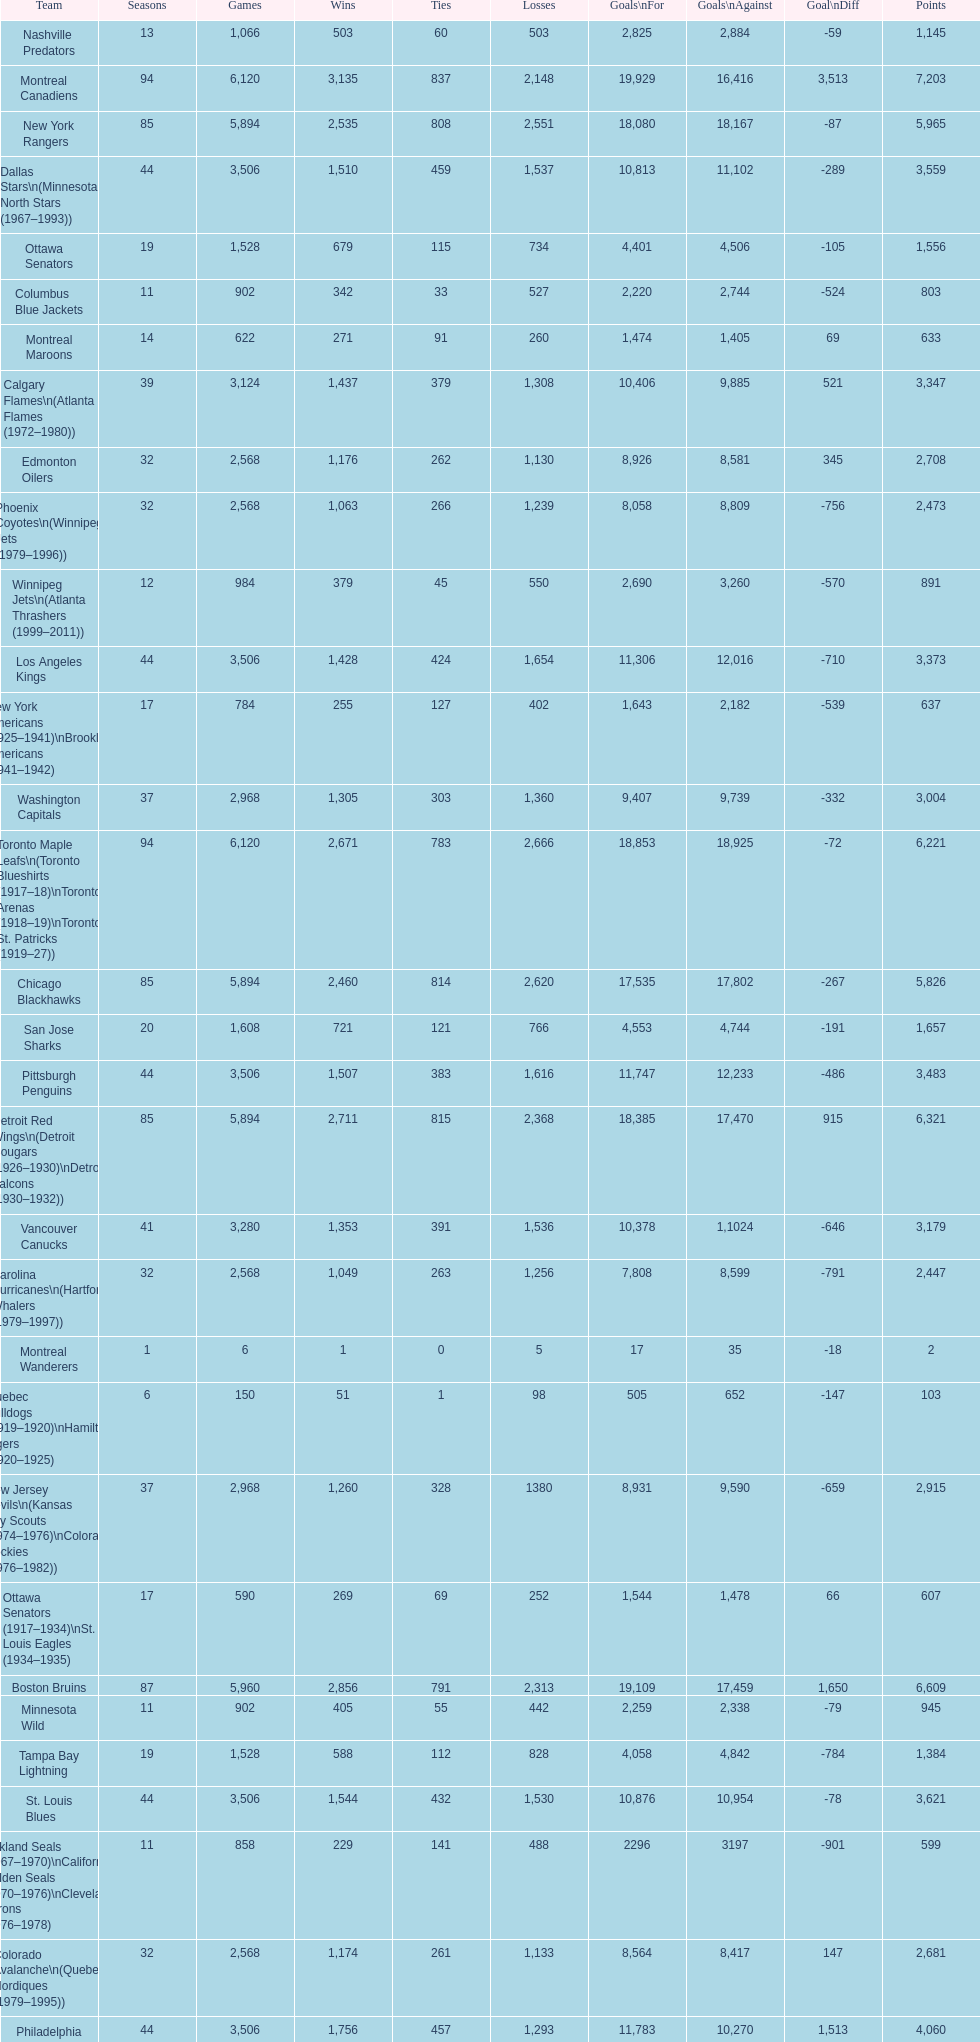How many losses do the st. louis blues have? 1,530. Can you give me this table as a dict? {'header': ['Team', 'Seasons', 'Games', 'Wins', 'Ties', 'Losses', 'Goals\\nFor', 'Goals\\nAgainst', 'Goal\\nDiff', 'Points'], 'rows': [['Nashville Predators', '13', '1,066', '503', '60', '503', '2,825', '2,884', '-59', '1,145'], ['Montreal Canadiens', '94', '6,120', '3,135', '837', '2,148', '19,929', '16,416', '3,513', '7,203'], ['New York Rangers', '85', '5,894', '2,535', '808', '2,551', '18,080', '18,167', '-87', '5,965'], ['Dallas Stars\\n(Minnesota North Stars (1967–1993))', '44', '3,506', '1,510', '459', '1,537', '10,813', '11,102', '-289', '3,559'], ['Ottawa Senators', '19', '1,528', '679', '115', '734', '4,401', '4,506', '-105', '1,556'], ['Columbus Blue Jackets', '11', '902', '342', '33', '527', '2,220', '2,744', '-524', '803'], ['Montreal Maroons', '14', '622', '271', '91', '260', '1,474', '1,405', '69', '633'], ['Calgary Flames\\n(Atlanta Flames (1972–1980))', '39', '3,124', '1,437', '379', '1,308', '10,406', '9,885', '521', '3,347'], ['Edmonton Oilers', '32', '2,568', '1,176', '262', '1,130', '8,926', '8,581', '345', '2,708'], ['Phoenix Coyotes\\n(Winnipeg Jets (1979–1996))', '32', '2,568', '1,063', '266', '1,239', '8,058', '8,809', '-756', '2,473'], ['Winnipeg Jets\\n(Atlanta Thrashers (1999–2011))', '12', '984', '379', '45', '550', '2,690', '3,260', '-570', '891'], ['Los Angeles Kings', '44', '3,506', '1,428', '424', '1,654', '11,306', '12,016', '-710', '3,373'], ['New York Americans (1925–1941)\\nBrooklyn Americans (1941–1942)', '17', '784', '255', '127', '402', '1,643', '2,182', '-539', '637'], ['Washington Capitals', '37', '2,968', '1,305', '303', '1,360', '9,407', '9,739', '-332', '3,004'], ['Toronto Maple Leafs\\n(Toronto Blueshirts (1917–18)\\nToronto Arenas (1918–19)\\nToronto St. Patricks (1919–27))', '94', '6,120', '2,671', '783', '2,666', '18,853', '18,925', '-72', '6,221'], ['Chicago Blackhawks', '85', '5,894', '2,460', '814', '2,620', '17,535', '17,802', '-267', '5,826'], ['San Jose Sharks', '20', '1,608', '721', '121', '766', '4,553', '4,744', '-191', '1,657'], ['Pittsburgh Penguins', '44', '3,506', '1,507', '383', '1,616', '11,747', '12,233', '-486', '3,483'], ['Detroit Red Wings\\n(Detroit Cougars (1926–1930)\\nDetroit Falcons (1930–1932))', '85', '5,894', '2,711', '815', '2,368', '18,385', '17,470', '915', '6,321'], ['Vancouver Canucks', '41', '3,280', '1,353', '391', '1,536', '10,378', '1,1024', '-646', '3,179'], ['Carolina Hurricanes\\n(Hartford Whalers (1979–1997))', '32', '2,568', '1,049', '263', '1,256', '7,808', '8,599', '-791', '2,447'], ['Montreal Wanderers', '1', '6', '1', '0', '5', '17', '35', '-18', '2'], ['Quebec Bulldogs (1919–1920)\\nHamilton Tigers (1920–1925)', '6', '150', '51', '1', '98', '505', '652', '-147', '103'], ['New Jersey Devils\\n(Kansas City Scouts (1974–1976)\\nColorado Rockies (1976–1982))', '37', '2,968', '1,260', '328', '1380', '8,931', '9,590', '-659', '2,915'], ['Ottawa Senators (1917–1934)\\nSt. Louis Eagles (1934–1935)', '17', '590', '269', '69', '252', '1,544', '1,478', '66', '607'], ['Boston Bruins', '87', '5,960', '2,856', '791', '2,313', '19,109', '17,459', '1,650', '6,609'], ['Minnesota Wild', '11', '902', '405', '55', '442', '2,259', '2,338', '-79', '945'], ['Tampa Bay Lightning', '19', '1,528', '588', '112', '828', '4,058', '4,842', '-784', '1,384'], ['St. Louis Blues', '44', '3,506', '1,544', '432', '1,530', '10,876', '10,954', '-78', '3,621'], ['Oakland Seals (1967–1970)\\nCalifornia Golden Seals (1970–1976)\\nCleveland Barons (1976–1978)', '11', '858', '229', '141', '488', '2296', '3197', '-901', '599'], ['Colorado Avalanche\\n(Quebec Nordiques (1979–1995))', '32', '2,568', '1,174', '261', '1,133', '8,564', '8,417', '147', '2,681'], ['Philadelphia Flyers', '44', '3,506', '1,756', '457', '1,293', '11,783', '10,270', '1,513', '4,060'], ['Florida Panthers', '18', '1,444', '573', '142', '729', '3,767', '4,113', '-346', '1,412'], ['Anaheim Ducks', '18', '1,444', '638', '107', '699', '3,863', '4,021', '-158', '1,477'], ['Pittsburgh Pirates (1925–1930)\\nPhiladelphia Quakers (1930–1931)', '6', '256', '71', '27', '158', '452', '703', '-251', '169'], ['New York Islanders', '39', '3,124', '1,347', '347', '1,430', '10,116', '10,000', '116', '3,126'], ['Buffalo Sabres', '41', '3,280', '1,569', '409', '1,302', '10,868', '9,875', '993', '3,630']]} 